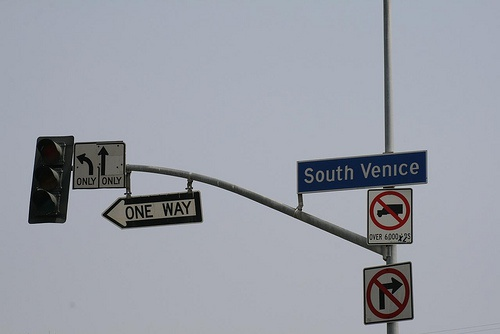Describe the objects in this image and their specific colors. I can see a traffic light in darkgray, black, and gray tones in this image. 